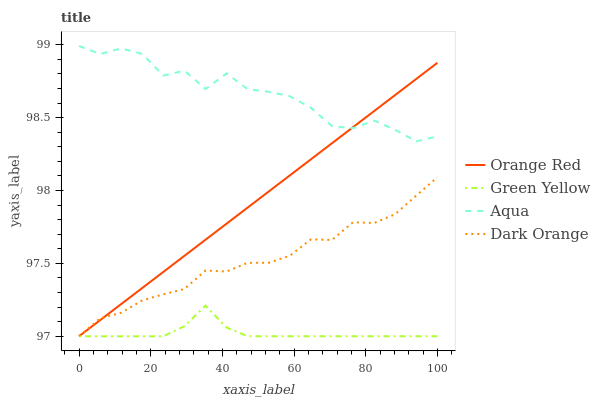Does Green Yellow have the minimum area under the curve?
Answer yes or no. Yes. Does Aqua have the maximum area under the curve?
Answer yes or no. Yes. Does Aqua have the minimum area under the curve?
Answer yes or no. No. Does Green Yellow have the maximum area under the curve?
Answer yes or no. No. Is Orange Red the smoothest?
Answer yes or no. Yes. Is Aqua the roughest?
Answer yes or no. Yes. Is Green Yellow the smoothest?
Answer yes or no. No. Is Green Yellow the roughest?
Answer yes or no. No. Does Aqua have the lowest value?
Answer yes or no. No. Does Aqua have the highest value?
Answer yes or no. Yes. Does Green Yellow have the highest value?
Answer yes or no. No. Is Dark Orange less than Aqua?
Answer yes or no. Yes. Is Aqua greater than Green Yellow?
Answer yes or no. Yes. Does Dark Orange intersect Aqua?
Answer yes or no. No. 